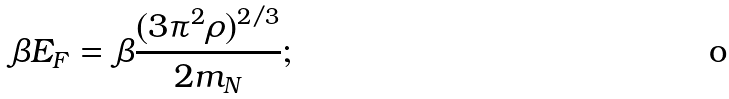Convert formula to latex. <formula><loc_0><loc_0><loc_500><loc_500>\beta E _ { F } = \beta \frac { ( 3 \pi ^ { 2 } \rho ) ^ { 2 / 3 } } { 2 m _ { N } } ;</formula> 